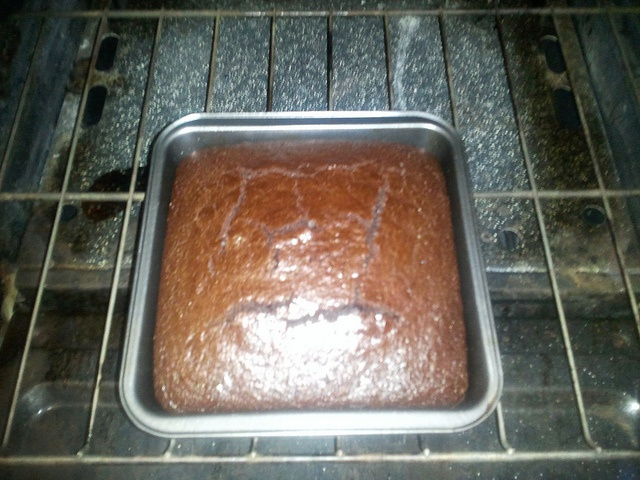Describe the objects in this image and their specific colors. I can see oven in black, gray, white, darkgray, and brown tones and cake in black, brown, white, and tan tones in this image. 